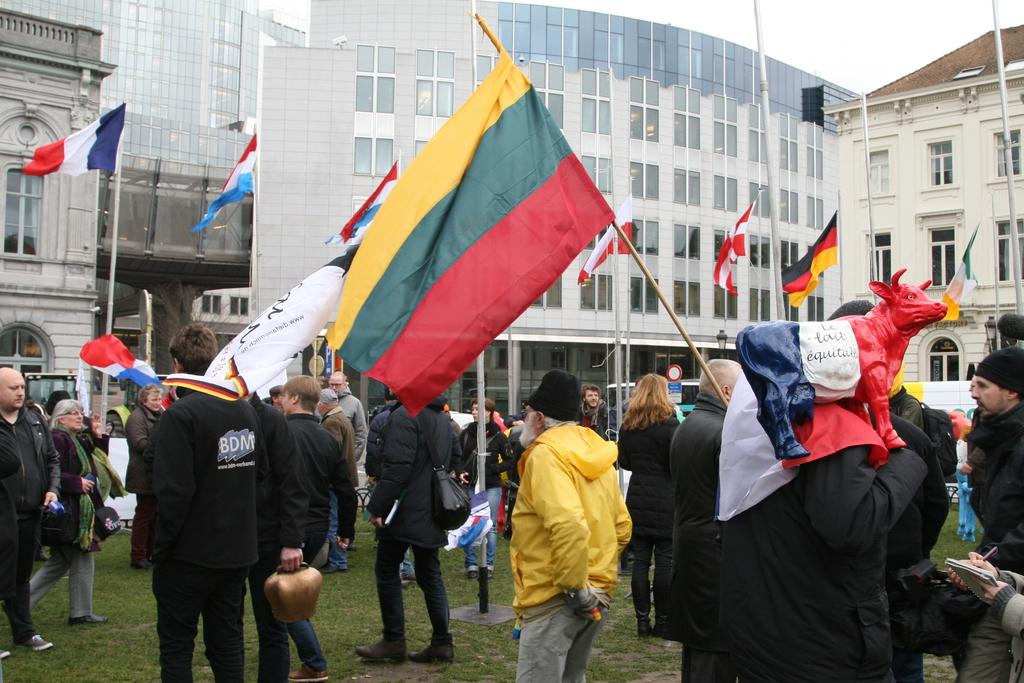What are the people in the image doing? The people in the image are standing on the ground and holding flags in their hands. What can be seen in the background of the image? There are many buildings visible in the background of the image. What type of wood can be seen on the dock in the image? There is no dock or wood present in the image; it features people standing on the ground and holding flags, with buildings in the background. 